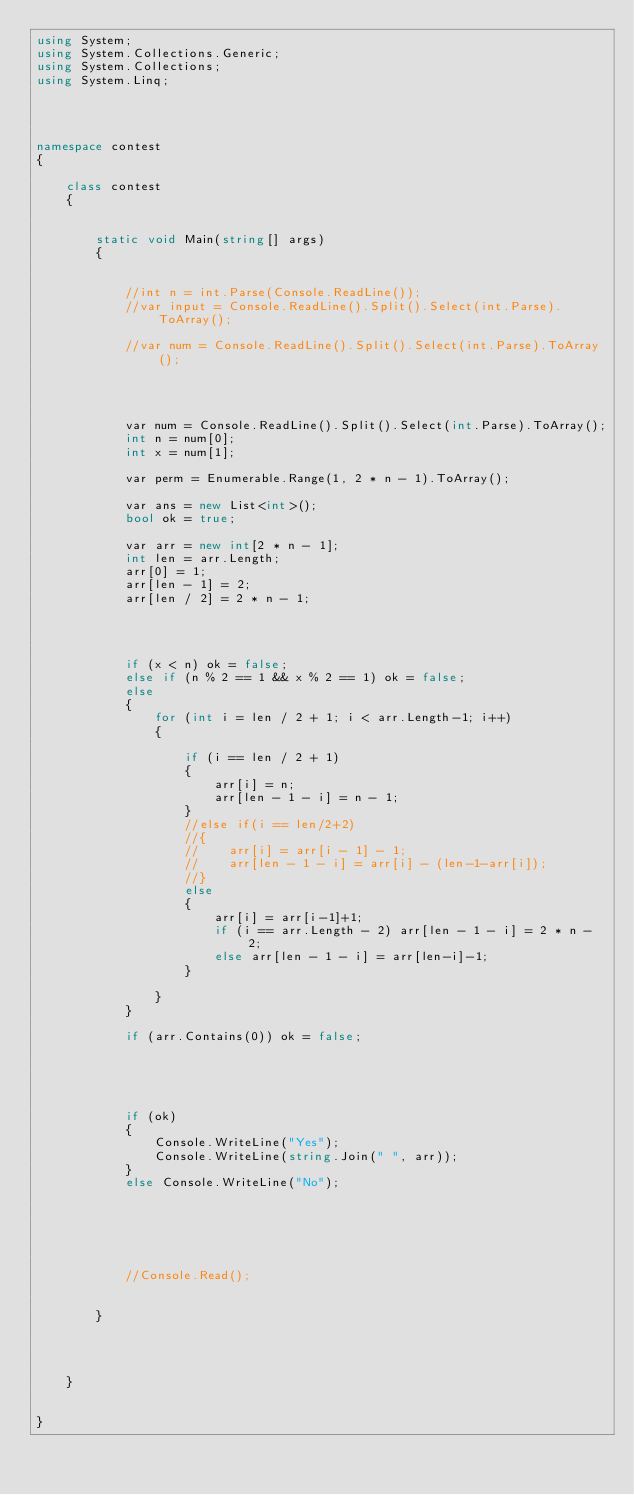<code> <loc_0><loc_0><loc_500><loc_500><_C#_>using System;
using System.Collections.Generic;
using System.Collections;
using System.Linq;




namespace contest
{

    class contest
    {


        static void Main(string[] args)
        {


            //int n = int.Parse(Console.ReadLine());
            //var input = Console.ReadLine().Split().Select(int.Parse).ToArray();

            //var num = Console.ReadLine().Split().Select(int.Parse).ToArray();




            var num = Console.ReadLine().Split().Select(int.Parse).ToArray();
            int n = num[0];
            int x = num[1];

            var perm = Enumerable.Range(1, 2 * n - 1).ToArray();

            var ans = new List<int>();
            bool ok = true;

            var arr = new int[2 * n - 1];
            int len = arr.Length;
            arr[0] = 1;
            arr[len - 1] = 2;
            arr[len / 2] = 2 * n - 1;

            


            if (x < n) ok = false;
            else if (n % 2 == 1 && x % 2 == 1) ok = false;
            else
            {
                for (int i = len / 2 + 1; i < arr.Length-1; i++)
                {

                    if (i == len / 2 + 1)
                    {
                        arr[i] = n;
                        arr[len - 1 - i] = n - 1;
                    }
                    //else if(i == len/2+2)
                    //{
                    //    arr[i] = arr[i - 1] - 1;
                    //    arr[len - 1 - i] = arr[i] - (len-1-arr[i]);
                    //}
                    else
                    {
                        arr[i] = arr[i-1]+1;
                        if (i == arr.Length - 2) arr[len - 1 - i] = 2 * n - 2;
                        else arr[len - 1 - i] = arr[len-i]-1;
                    }

                }
            }

            if (arr.Contains(0)) ok = false;

            



            if (ok)
            {
                Console.WriteLine("Yes");
                Console.WriteLine(string.Join(" ", arr));
            }
            else Console.WriteLine("No");






            //Console.Read();


        }

        


    }


}
</code> 